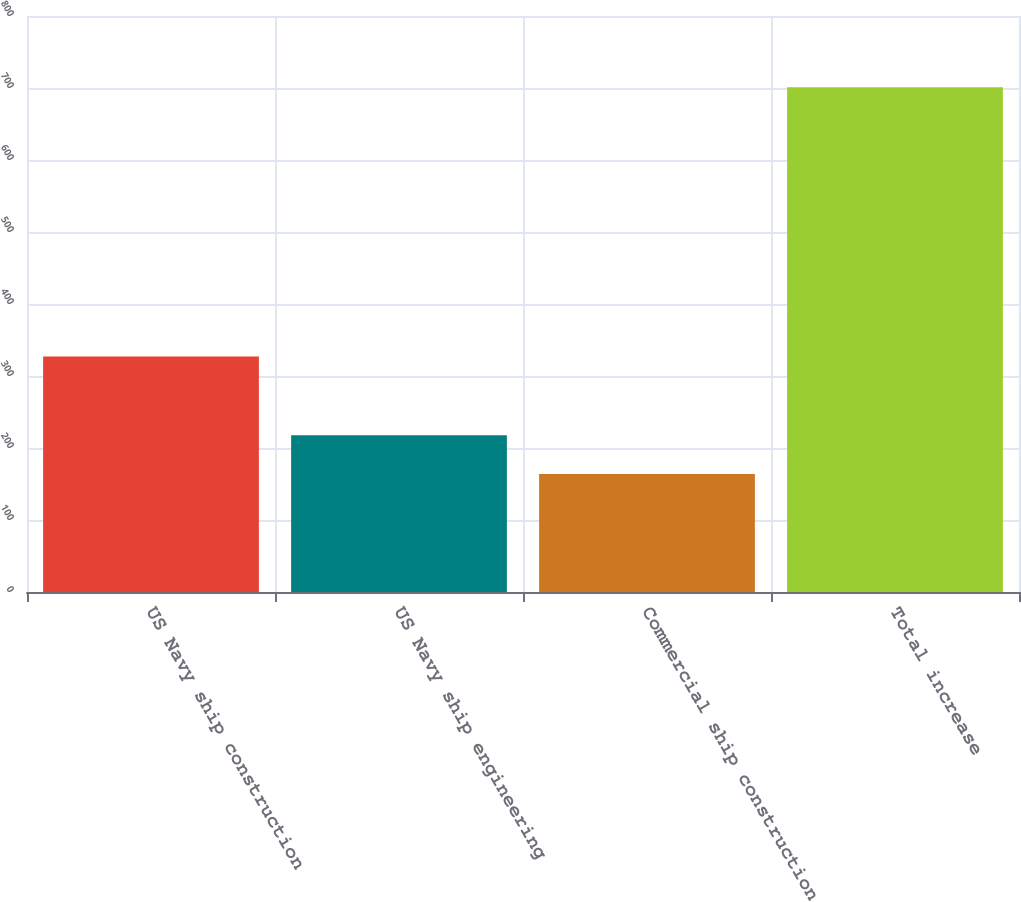Convert chart to OTSL. <chart><loc_0><loc_0><loc_500><loc_500><bar_chart><fcel>US Navy ship construction<fcel>US Navy ship engineering<fcel>Commercial ship construction<fcel>Total increase<nl><fcel>327<fcel>217.7<fcel>164<fcel>701<nl></chart> 